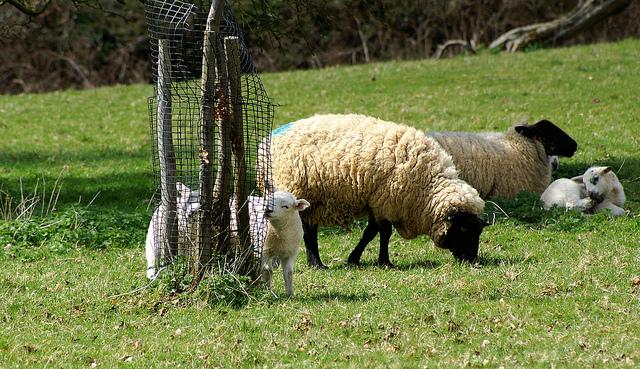How many sheep are depicted?
Quick response, please. 5. What color is the pasture?
Be succinct. Green. Are there any baby sheep?
Concise answer only. Yes. What are two products derived from these animals?
Short answer required. Wood and meat. 